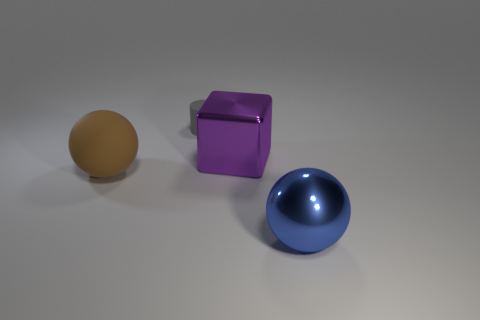Are there more large blocks that are left of the matte ball than balls that are behind the large blue object?
Offer a terse response. No. Does the brown matte sphere have the same size as the matte thing right of the brown object?
Your answer should be compact. No. How many cubes are either big brown matte objects or large purple metallic objects?
Your answer should be very brief. 1. There is a sphere that is made of the same material as the small cylinder; what is its size?
Offer a very short reply. Large. Do the metallic object behind the large shiny sphere and the thing that is in front of the brown ball have the same size?
Offer a very short reply. Yes. What number of objects are either big blue shiny cubes or large objects?
Provide a short and direct response. 3. What is the shape of the large brown thing?
Your response must be concise. Sphere. There is a brown object that is the same shape as the blue thing; what is its size?
Give a very brief answer. Large. There is a rubber object right of the big sphere that is to the left of the gray cylinder; what size is it?
Keep it short and to the point. Small. Are there an equal number of big brown rubber balls that are on the left side of the big matte ball and large yellow matte things?
Ensure brevity in your answer.  Yes. 